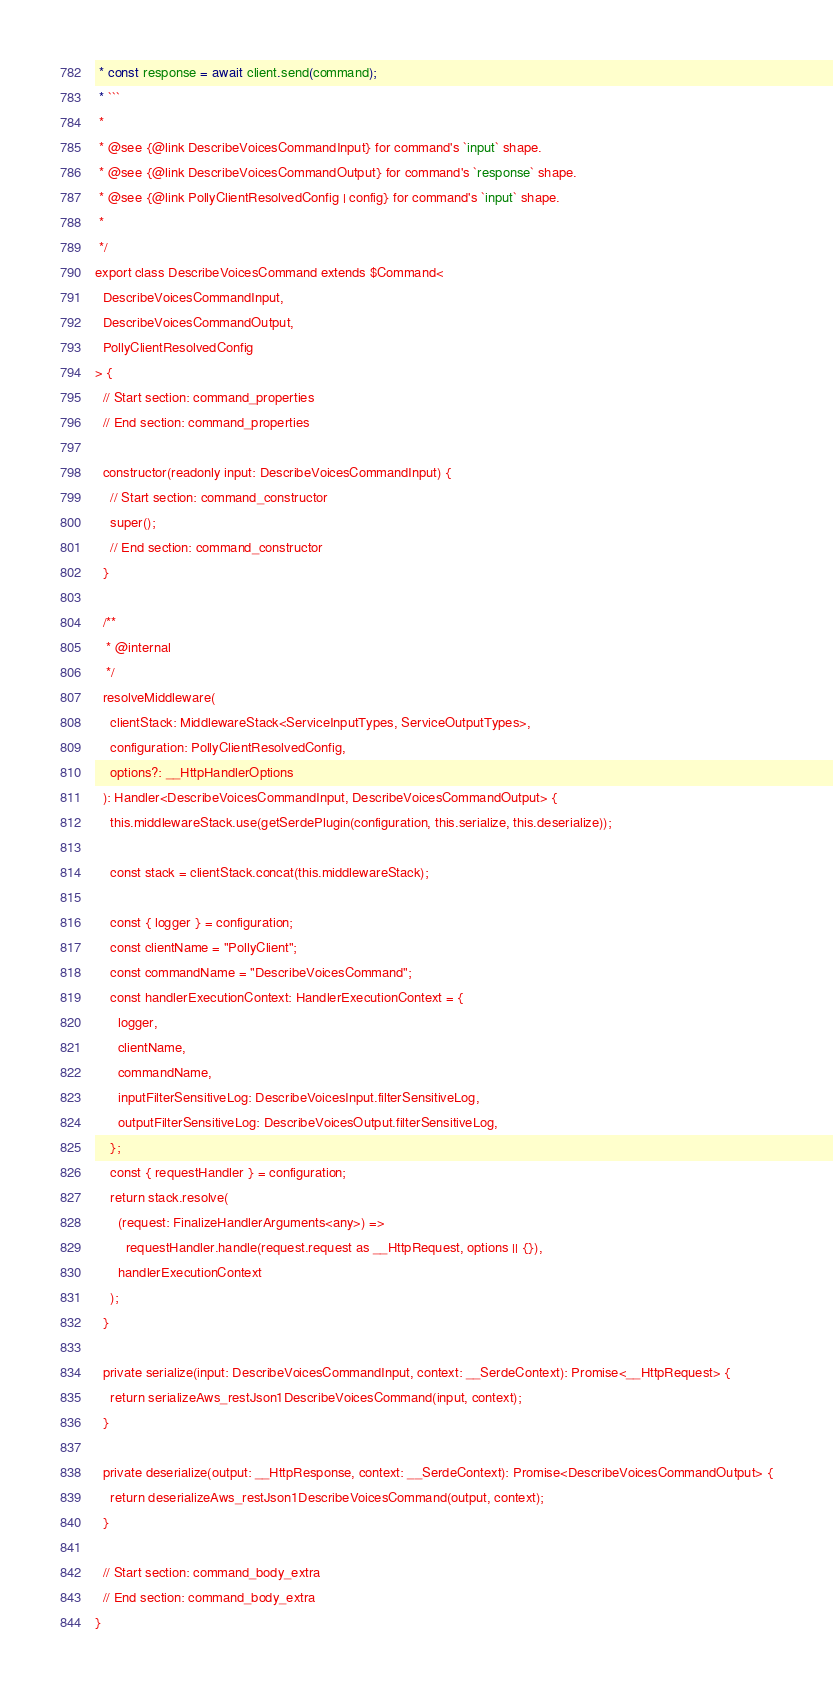<code> <loc_0><loc_0><loc_500><loc_500><_TypeScript_> * const response = await client.send(command);
 * ```
 *
 * @see {@link DescribeVoicesCommandInput} for command's `input` shape.
 * @see {@link DescribeVoicesCommandOutput} for command's `response` shape.
 * @see {@link PollyClientResolvedConfig | config} for command's `input` shape.
 *
 */
export class DescribeVoicesCommand extends $Command<
  DescribeVoicesCommandInput,
  DescribeVoicesCommandOutput,
  PollyClientResolvedConfig
> {
  // Start section: command_properties
  // End section: command_properties

  constructor(readonly input: DescribeVoicesCommandInput) {
    // Start section: command_constructor
    super();
    // End section: command_constructor
  }

  /**
   * @internal
   */
  resolveMiddleware(
    clientStack: MiddlewareStack<ServiceInputTypes, ServiceOutputTypes>,
    configuration: PollyClientResolvedConfig,
    options?: __HttpHandlerOptions
  ): Handler<DescribeVoicesCommandInput, DescribeVoicesCommandOutput> {
    this.middlewareStack.use(getSerdePlugin(configuration, this.serialize, this.deserialize));

    const stack = clientStack.concat(this.middlewareStack);

    const { logger } = configuration;
    const clientName = "PollyClient";
    const commandName = "DescribeVoicesCommand";
    const handlerExecutionContext: HandlerExecutionContext = {
      logger,
      clientName,
      commandName,
      inputFilterSensitiveLog: DescribeVoicesInput.filterSensitiveLog,
      outputFilterSensitiveLog: DescribeVoicesOutput.filterSensitiveLog,
    };
    const { requestHandler } = configuration;
    return stack.resolve(
      (request: FinalizeHandlerArguments<any>) =>
        requestHandler.handle(request.request as __HttpRequest, options || {}),
      handlerExecutionContext
    );
  }

  private serialize(input: DescribeVoicesCommandInput, context: __SerdeContext): Promise<__HttpRequest> {
    return serializeAws_restJson1DescribeVoicesCommand(input, context);
  }

  private deserialize(output: __HttpResponse, context: __SerdeContext): Promise<DescribeVoicesCommandOutput> {
    return deserializeAws_restJson1DescribeVoicesCommand(output, context);
  }

  // Start section: command_body_extra
  // End section: command_body_extra
}
</code> 